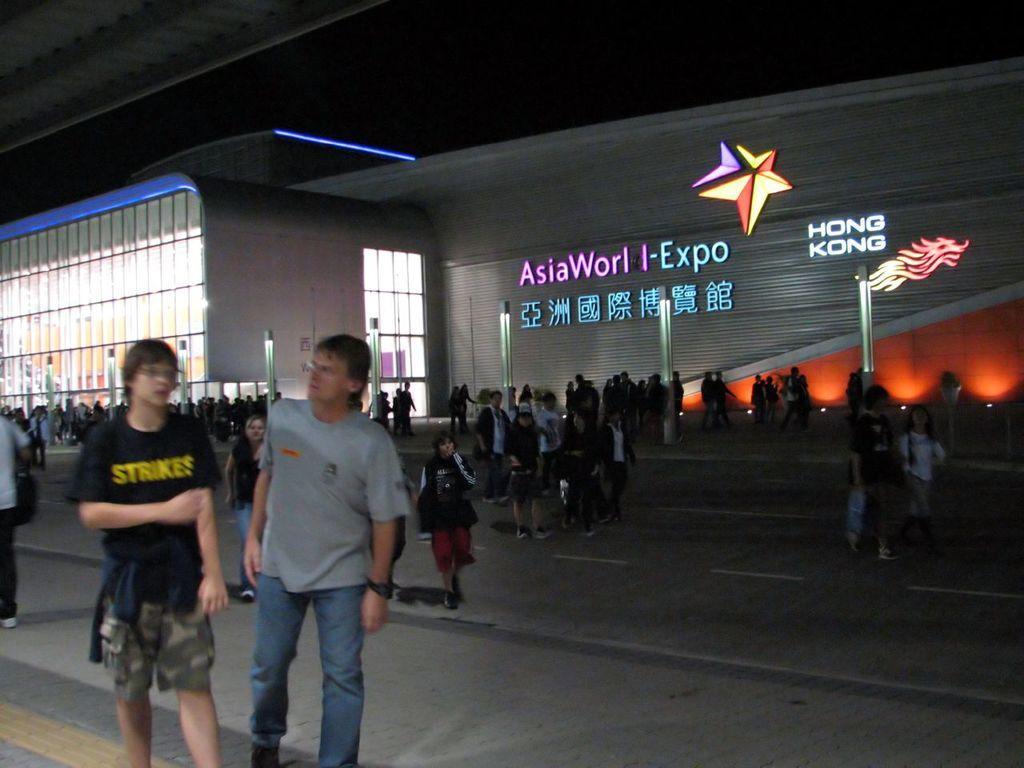How would you summarize this image in a sentence or two? In this image we can see a building, which consists of some text and logos on it, in front of it there are poles and a group of people. 